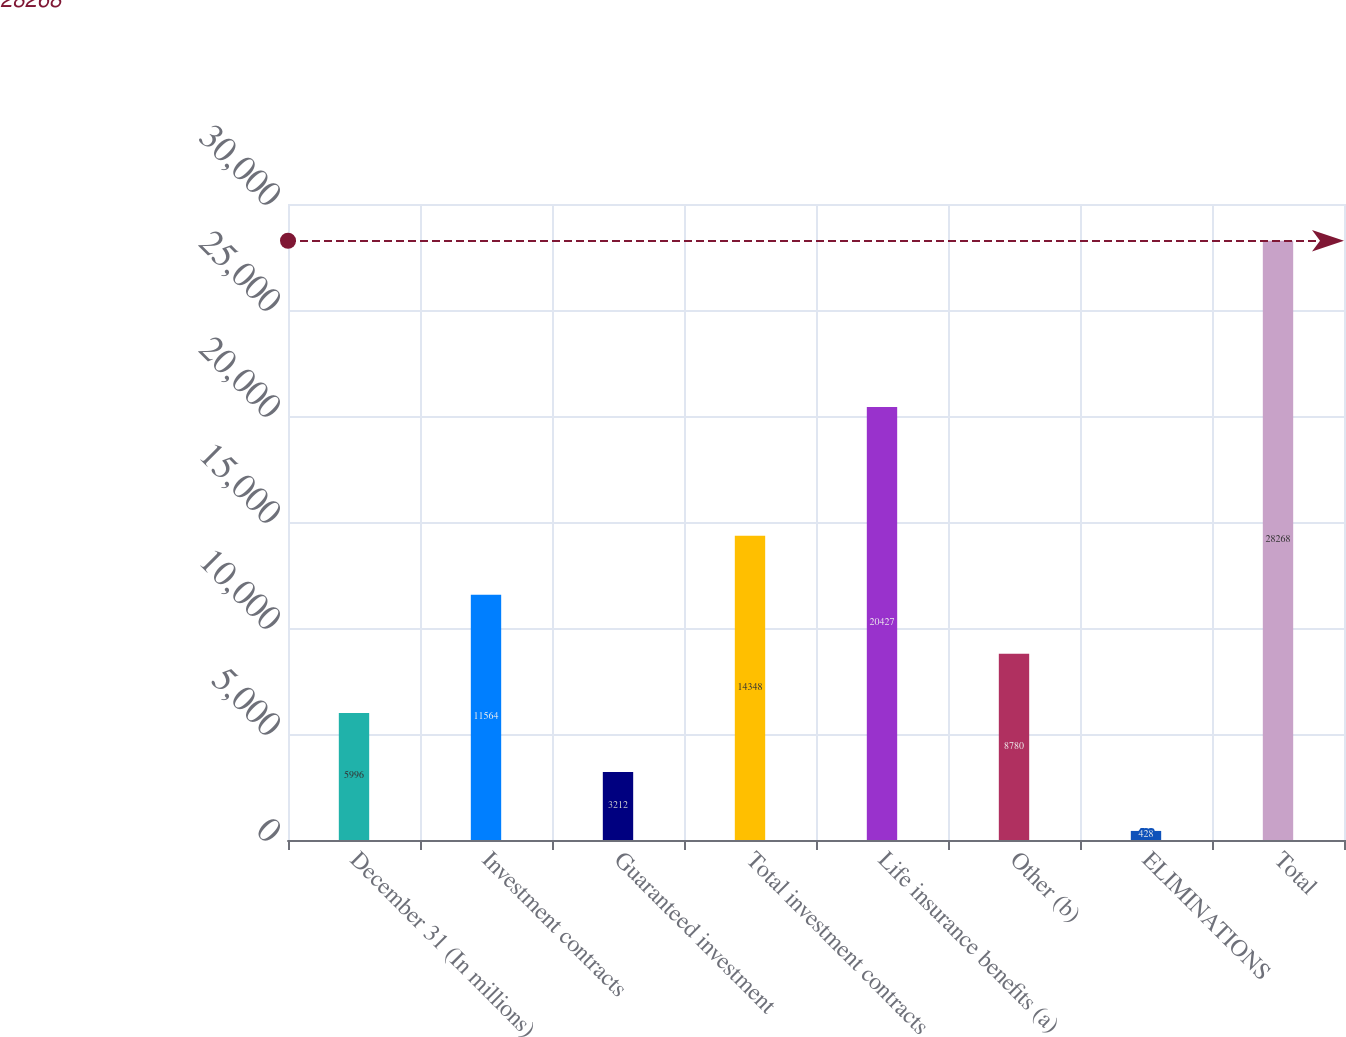Convert chart. <chart><loc_0><loc_0><loc_500><loc_500><bar_chart><fcel>December 31 (In millions)<fcel>Investment contracts<fcel>Guaranteed investment<fcel>Total investment contracts<fcel>Life insurance benefits (a)<fcel>Other (b)<fcel>ELIMINATIONS<fcel>Total<nl><fcel>5996<fcel>11564<fcel>3212<fcel>14348<fcel>20427<fcel>8780<fcel>428<fcel>28268<nl></chart> 